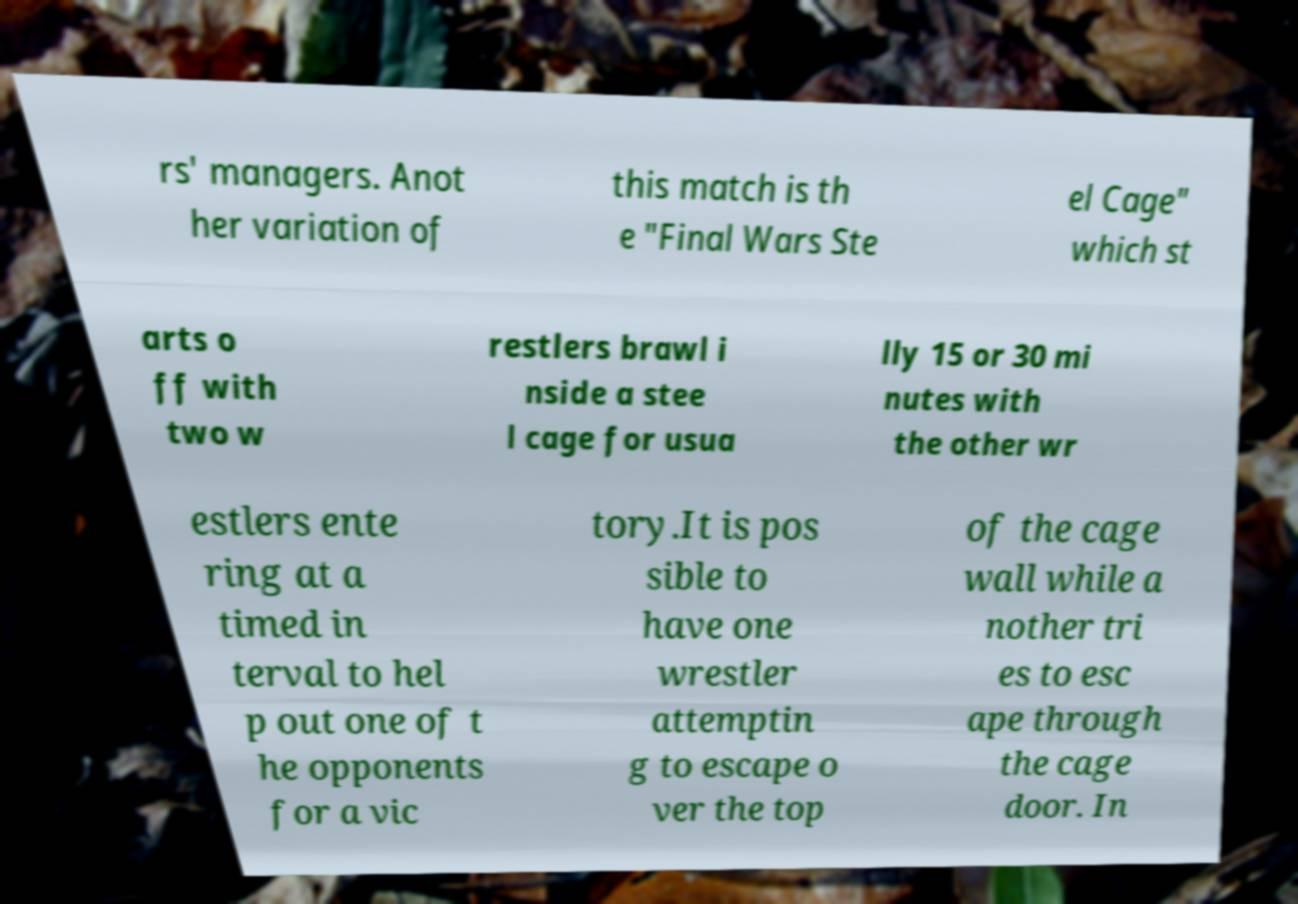Could you extract and type out the text from this image? rs' managers. Anot her variation of this match is th e "Final Wars Ste el Cage" which st arts o ff with two w restlers brawl i nside a stee l cage for usua lly 15 or 30 mi nutes with the other wr estlers ente ring at a timed in terval to hel p out one of t he opponents for a vic tory.It is pos sible to have one wrestler attemptin g to escape o ver the top of the cage wall while a nother tri es to esc ape through the cage door. In 